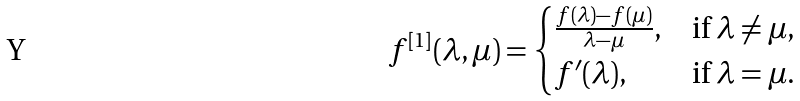<formula> <loc_0><loc_0><loc_500><loc_500>f ^ { [ 1 ] } ( \lambda , \mu ) = \begin{cases} \frac { f ( \lambda ) - f ( \mu ) } { \lambda - \mu } , & \text {if $\lambda\neq\mu$} , \\ f ^ { \prime } ( \lambda ) , & \text {if $\lambda=\mu$} . \end{cases}</formula> 